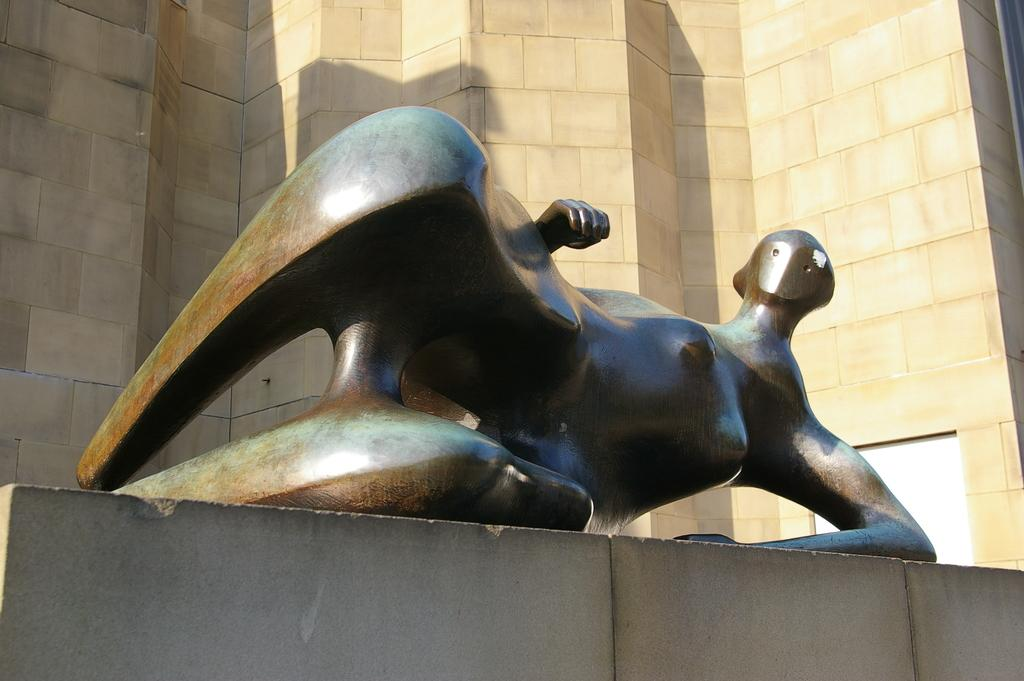What is the main subject in the image? There is a statue in the image. How is the statue positioned? The statue is lying on a base. What can be seen in the background of the image? There is a wall in the background of the image. What type of boundary can be seen in the image? There is no boundary visible in the image; it features a statue lying on a base with a wall in the background. Can you tell me how many goats are present in the image? There are no goats present in the image. 